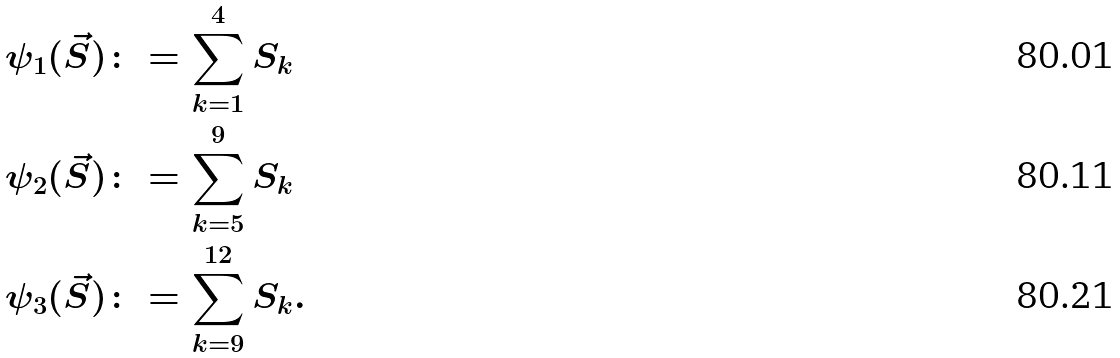<formula> <loc_0><loc_0><loc_500><loc_500>\psi _ { 1 } ( \vec { S } ) & \colon = \sum _ { k = 1 } ^ { 4 } S _ { k } \\ \psi _ { 2 } ( \vec { S } ) & \colon = \sum _ { k = 5 } ^ { 9 } S _ { k } \\ \psi _ { 3 } ( \vec { S } ) & \colon = \sum _ { k = 9 } ^ { 1 2 } S _ { k } .</formula> 